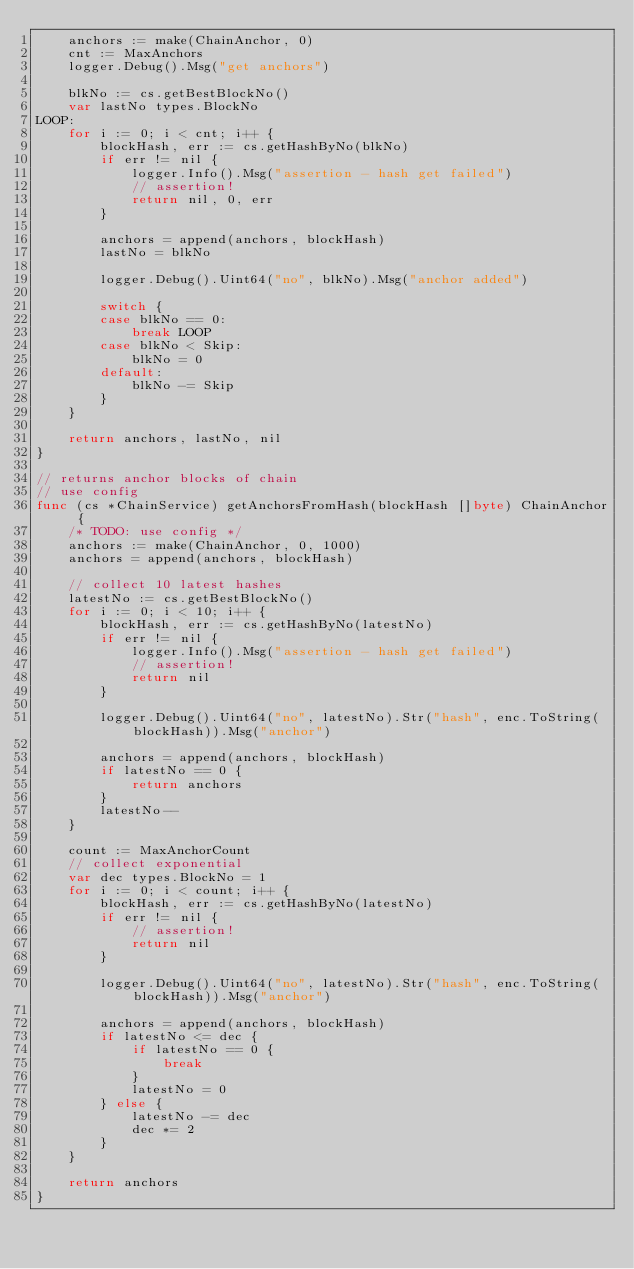<code> <loc_0><loc_0><loc_500><loc_500><_Go_>	anchors := make(ChainAnchor, 0)
	cnt := MaxAnchors
	logger.Debug().Msg("get anchors")

	blkNo := cs.getBestBlockNo()
	var lastNo types.BlockNo
LOOP:
	for i := 0; i < cnt; i++ {
		blockHash, err := cs.getHashByNo(blkNo)
		if err != nil {
			logger.Info().Msg("assertion - hash get failed")
			// assertion!
			return nil, 0, err
		}

		anchors = append(anchors, blockHash)
		lastNo = blkNo

		logger.Debug().Uint64("no", blkNo).Msg("anchor added")

		switch {
		case blkNo == 0:
			break LOOP
		case blkNo < Skip:
			blkNo = 0
		default:
			blkNo -= Skip
		}
	}

	return anchors, lastNo, nil
}

// returns anchor blocks of chain
// use config
func (cs *ChainService) getAnchorsFromHash(blockHash []byte) ChainAnchor {
	/* TODO: use config */
	anchors := make(ChainAnchor, 0, 1000)
	anchors = append(anchors, blockHash)

	// collect 10 latest hashes
	latestNo := cs.getBestBlockNo()
	for i := 0; i < 10; i++ {
		blockHash, err := cs.getHashByNo(latestNo)
		if err != nil {
			logger.Info().Msg("assertion - hash get failed")
			// assertion!
			return nil
		}

		logger.Debug().Uint64("no", latestNo).Str("hash", enc.ToString(blockHash)).Msg("anchor")

		anchors = append(anchors, blockHash)
		if latestNo == 0 {
			return anchors
		}
		latestNo--
	}

	count := MaxAnchorCount
	// collect exponential
	var dec types.BlockNo = 1
	for i := 0; i < count; i++ {
		blockHash, err := cs.getHashByNo(latestNo)
		if err != nil {
			// assertion!
			return nil
		}

		logger.Debug().Uint64("no", latestNo).Str("hash", enc.ToString(blockHash)).Msg("anchor")

		anchors = append(anchors, blockHash)
		if latestNo <= dec {
			if latestNo == 0 {
				break
			}
			latestNo = 0
		} else {
			latestNo -= dec
			dec *= 2
		}
	}

	return anchors
}
</code> 